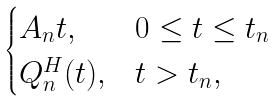Convert formula to latex. <formula><loc_0><loc_0><loc_500><loc_500>\begin{cases} A _ { n } t , & 0 \leq t \leq t _ { n } \\ Q _ { n } ^ { H } ( t ) , & t > t _ { n } , \end{cases}</formula> 